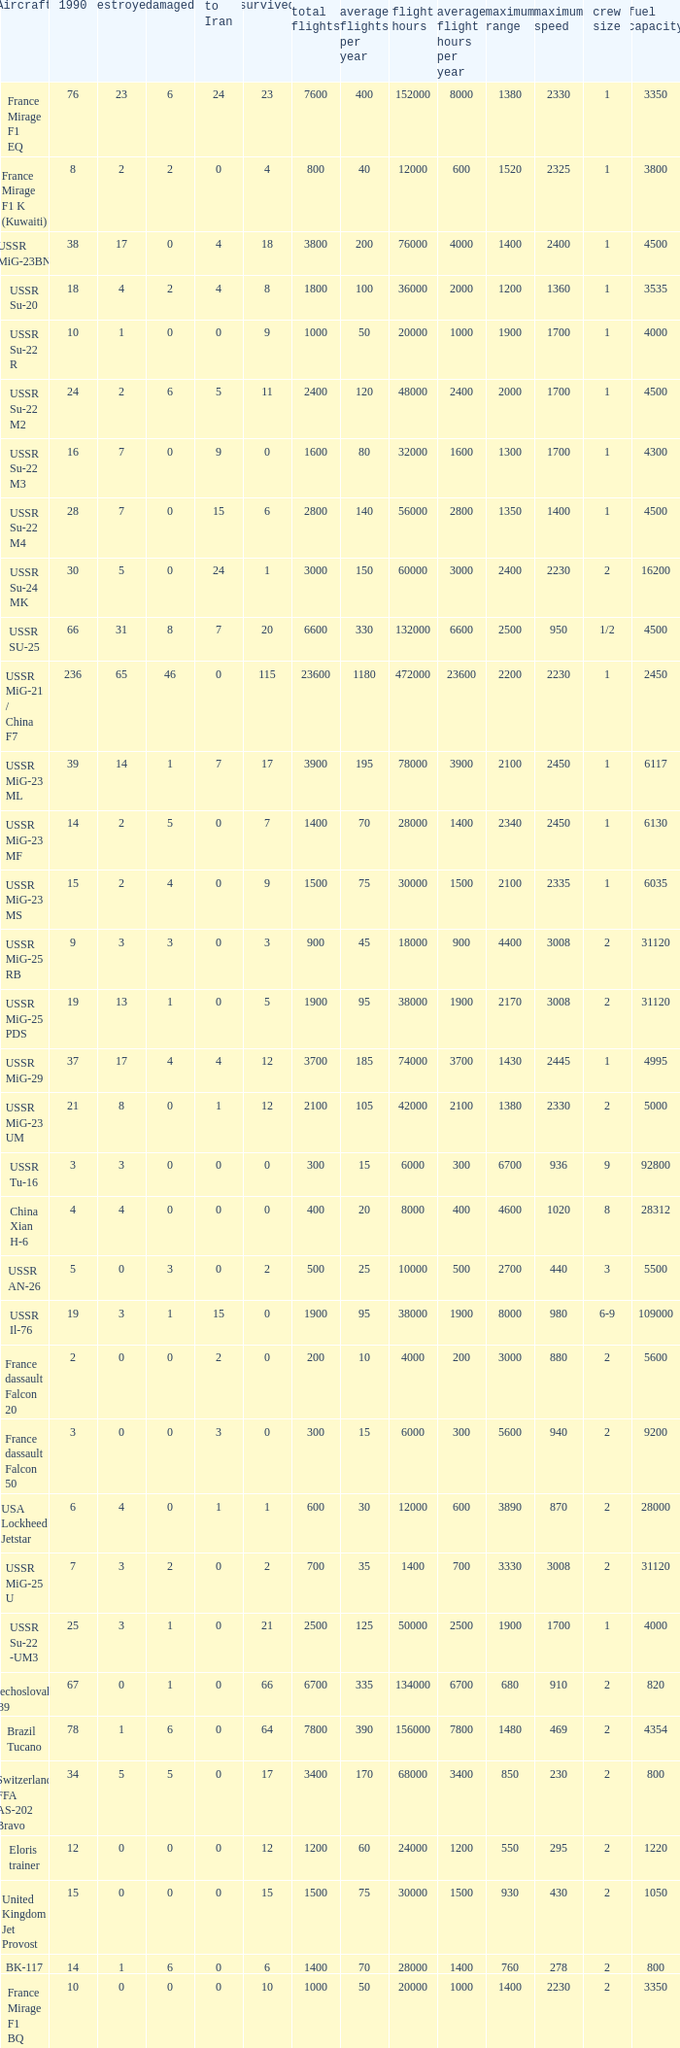If the aircraft was  ussr mig-25 rb how many were destroyed? 3.0. 